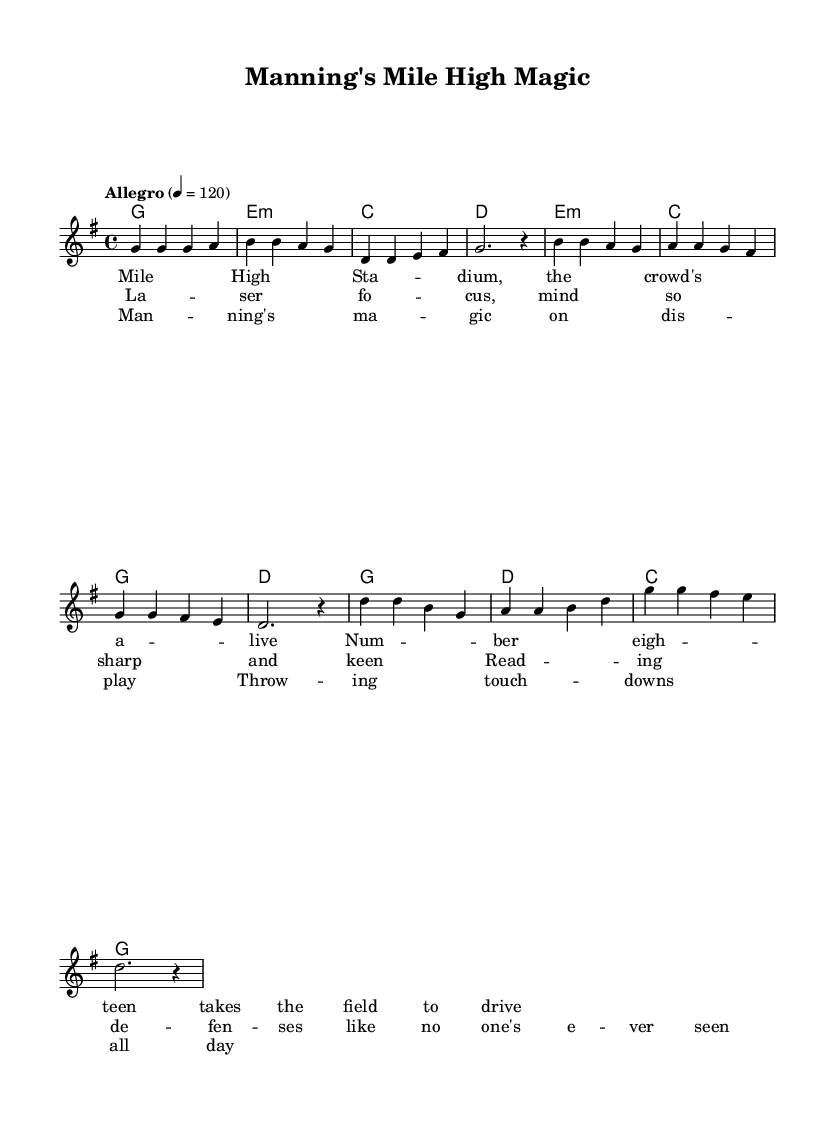What is the key signature of this music? The key signature is G major, which has one sharp (F#). This is indicated in the global settings at the beginning of the score.
Answer: G major What is the time signature of this piece? The time signature is 4/4, which indicates that there are four beats in each measure and the quarter note gets one beat. This is also noted in the global settings.
Answer: 4/4 What is the tempo marking for the piece? The tempo marking is "Allegro," which indicates a fast and lively pace. It is specified in the global settings, along with a tempo of quarter note = 120 beats per minute.
Answer: Allegro How many measures are in the verse section? The verse section contains four measures. Each measure is filled with notes or rests, and counting them from the melody, we identify four distinct measures.
Answer: Four What is the mood conveyed in the pre-chorus lyrics? The mood is focused and intense, as the lyrics describe a player reading defenses and being sharp-minded, emphasizing a heightened state of concentration. This aligns with the theme of celebrating Peyton Manning's abilities.
Answer: Focused Which quarterback is celebrated in this piece? The piece focuses on Peyton Manning, highlighting his skills and achievements. The lyrics reference his number and create a celebratory atmosphere around his presence in the game.
Answer: Peyton Manning What musical device is used in the chorus to emphasize Manning's abilities? The chorus employs repetition, repeating phrases about "Manning's magic" to create an anthem-like quality that reinforces the excitement and admiration. This enhances the celebratory nature of the song.
Answer: Repetition 